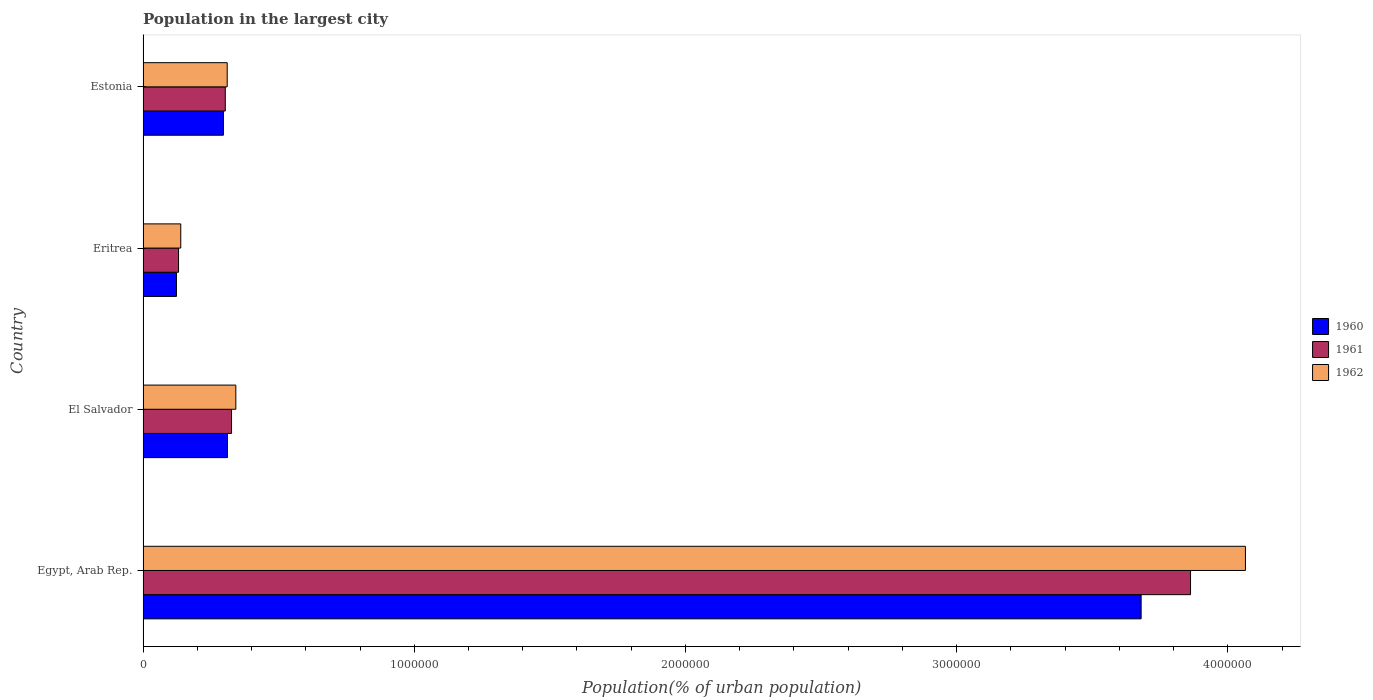How many bars are there on the 4th tick from the top?
Keep it short and to the point. 3. How many bars are there on the 4th tick from the bottom?
Ensure brevity in your answer.  3. What is the label of the 4th group of bars from the top?
Your response must be concise. Egypt, Arab Rep. In how many cases, is the number of bars for a given country not equal to the number of legend labels?
Give a very brief answer. 0. What is the population in the largest city in 1960 in Eritrea?
Offer a very short reply. 1.23e+05. Across all countries, what is the maximum population in the largest city in 1960?
Offer a terse response. 3.68e+06. Across all countries, what is the minimum population in the largest city in 1961?
Provide a short and direct response. 1.31e+05. In which country was the population in the largest city in 1960 maximum?
Ensure brevity in your answer.  Egypt, Arab Rep. In which country was the population in the largest city in 1962 minimum?
Your answer should be compact. Eritrea. What is the total population in the largest city in 1960 in the graph?
Offer a terse response. 4.41e+06. What is the difference between the population in the largest city in 1960 in El Salvador and that in Eritrea?
Keep it short and to the point. 1.88e+05. What is the difference between the population in the largest city in 1960 in El Salvador and the population in the largest city in 1962 in Egypt, Arab Rep.?
Your answer should be very brief. -3.75e+06. What is the average population in the largest city in 1961 per country?
Keep it short and to the point. 1.16e+06. What is the difference between the population in the largest city in 1960 and population in the largest city in 1962 in El Salvador?
Offer a terse response. -3.08e+04. What is the ratio of the population in the largest city in 1960 in El Salvador to that in Estonia?
Provide a short and direct response. 1.05. What is the difference between the highest and the second highest population in the largest city in 1960?
Ensure brevity in your answer.  3.37e+06. What is the difference between the highest and the lowest population in the largest city in 1962?
Ensure brevity in your answer.  3.93e+06. In how many countries, is the population in the largest city in 1960 greater than the average population in the largest city in 1960 taken over all countries?
Provide a short and direct response. 1. What does the 1st bar from the bottom in Egypt, Arab Rep. represents?
Your answer should be compact. 1960. How many bars are there?
Your answer should be very brief. 12. Are all the bars in the graph horizontal?
Provide a short and direct response. Yes. How many countries are there in the graph?
Provide a succinct answer. 4. What is the difference between two consecutive major ticks on the X-axis?
Make the answer very short. 1.00e+06. Does the graph contain any zero values?
Make the answer very short. No. Does the graph contain grids?
Provide a succinct answer. No. How many legend labels are there?
Ensure brevity in your answer.  3. What is the title of the graph?
Provide a succinct answer. Population in the largest city. What is the label or title of the X-axis?
Offer a terse response. Population(% of urban population). What is the Population(% of urban population) in 1960 in Egypt, Arab Rep.?
Your answer should be very brief. 3.68e+06. What is the Population(% of urban population) in 1961 in Egypt, Arab Rep.?
Offer a terse response. 3.86e+06. What is the Population(% of urban population) in 1962 in Egypt, Arab Rep.?
Your answer should be very brief. 4.06e+06. What is the Population(% of urban population) in 1960 in El Salvador?
Offer a very short reply. 3.11e+05. What is the Population(% of urban population) of 1961 in El Salvador?
Provide a succinct answer. 3.26e+05. What is the Population(% of urban population) of 1962 in El Salvador?
Give a very brief answer. 3.42e+05. What is the Population(% of urban population) in 1960 in Eritrea?
Your response must be concise. 1.23e+05. What is the Population(% of urban population) in 1961 in Eritrea?
Your answer should be compact. 1.31e+05. What is the Population(% of urban population) of 1962 in Eritrea?
Provide a succinct answer. 1.39e+05. What is the Population(% of urban population) of 1960 in Estonia?
Provide a succinct answer. 2.96e+05. What is the Population(% of urban population) of 1961 in Estonia?
Keep it short and to the point. 3.03e+05. What is the Population(% of urban population) in 1962 in Estonia?
Ensure brevity in your answer.  3.10e+05. Across all countries, what is the maximum Population(% of urban population) of 1960?
Keep it short and to the point. 3.68e+06. Across all countries, what is the maximum Population(% of urban population) of 1961?
Your answer should be compact. 3.86e+06. Across all countries, what is the maximum Population(% of urban population) in 1962?
Ensure brevity in your answer.  4.06e+06. Across all countries, what is the minimum Population(% of urban population) in 1960?
Your answer should be very brief. 1.23e+05. Across all countries, what is the minimum Population(% of urban population) of 1961?
Provide a short and direct response. 1.31e+05. Across all countries, what is the minimum Population(% of urban population) of 1962?
Provide a short and direct response. 1.39e+05. What is the total Population(% of urban population) of 1960 in the graph?
Offer a very short reply. 4.41e+06. What is the total Population(% of urban population) of 1961 in the graph?
Provide a short and direct response. 4.62e+06. What is the total Population(% of urban population) in 1962 in the graph?
Give a very brief answer. 4.86e+06. What is the difference between the Population(% of urban population) of 1960 in Egypt, Arab Rep. and that in El Salvador?
Make the answer very short. 3.37e+06. What is the difference between the Population(% of urban population) of 1961 in Egypt, Arab Rep. and that in El Salvador?
Offer a terse response. 3.54e+06. What is the difference between the Population(% of urban population) in 1962 in Egypt, Arab Rep. and that in El Salvador?
Make the answer very short. 3.72e+06. What is the difference between the Population(% of urban population) of 1960 in Egypt, Arab Rep. and that in Eritrea?
Give a very brief answer. 3.56e+06. What is the difference between the Population(% of urban population) in 1961 in Egypt, Arab Rep. and that in Eritrea?
Provide a short and direct response. 3.73e+06. What is the difference between the Population(% of urban population) of 1962 in Egypt, Arab Rep. and that in Eritrea?
Provide a short and direct response. 3.93e+06. What is the difference between the Population(% of urban population) in 1960 in Egypt, Arab Rep. and that in Estonia?
Keep it short and to the point. 3.38e+06. What is the difference between the Population(% of urban population) in 1961 in Egypt, Arab Rep. and that in Estonia?
Ensure brevity in your answer.  3.56e+06. What is the difference between the Population(% of urban population) of 1962 in Egypt, Arab Rep. and that in Estonia?
Your response must be concise. 3.75e+06. What is the difference between the Population(% of urban population) of 1960 in El Salvador and that in Eritrea?
Offer a very short reply. 1.88e+05. What is the difference between the Population(% of urban population) of 1961 in El Salvador and that in Eritrea?
Your answer should be compact. 1.95e+05. What is the difference between the Population(% of urban population) in 1962 in El Salvador and that in Eritrea?
Make the answer very short. 2.03e+05. What is the difference between the Population(% of urban population) of 1960 in El Salvador and that in Estonia?
Give a very brief answer. 1.49e+04. What is the difference between the Population(% of urban population) of 1961 in El Salvador and that in Estonia?
Provide a succinct answer. 2.30e+04. What is the difference between the Population(% of urban population) of 1962 in El Salvador and that in Estonia?
Give a very brief answer. 3.18e+04. What is the difference between the Population(% of urban population) in 1960 in Eritrea and that in Estonia?
Provide a short and direct response. -1.73e+05. What is the difference between the Population(% of urban population) of 1961 in Eritrea and that in Estonia?
Offer a terse response. -1.72e+05. What is the difference between the Population(% of urban population) of 1962 in Eritrea and that in Estonia?
Provide a succinct answer. -1.71e+05. What is the difference between the Population(% of urban population) in 1960 in Egypt, Arab Rep. and the Population(% of urban population) in 1961 in El Salvador?
Your answer should be very brief. 3.35e+06. What is the difference between the Population(% of urban population) in 1960 in Egypt, Arab Rep. and the Population(% of urban population) in 1962 in El Salvador?
Provide a short and direct response. 3.34e+06. What is the difference between the Population(% of urban population) in 1961 in Egypt, Arab Rep. and the Population(% of urban population) in 1962 in El Salvador?
Offer a very short reply. 3.52e+06. What is the difference between the Population(% of urban population) in 1960 in Egypt, Arab Rep. and the Population(% of urban population) in 1961 in Eritrea?
Give a very brief answer. 3.55e+06. What is the difference between the Population(% of urban population) of 1960 in Egypt, Arab Rep. and the Population(% of urban population) of 1962 in Eritrea?
Keep it short and to the point. 3.54e+06. What is the difference between the Population(% of urban population) of 1961 in Egypt, Arab Rep. and the Population(% of urban population) of 1962 in Eritrea?
Make the answer very short. 3.72e+06. What is the difference between the Population(% of urban population) in 1960 in Egypt, Arab Rep. and the Population(% of urban population) in 1961 in Estonia?
Your answer should be very brief. 3.38e+06. What is the difference between the Population(% of urban population) in 1960 in Egypt, Arab Rep. and the Population(% of urban population) in 1962 in Estonia?
Make the answer very short. 3.37e+06. What is the difference between the Population(% of urban population) of 1961 in Egypt, Arab Rep. and the Population(% of urban population) of 1962 in Estonia?
Offer a very short reply. 3.55e+06. What is the difference between the Population(% of urban population) of 1960 in El Salvador and the Population(% of urban population) of 1961 in Eritrea?
Keep it short and to the point. 1.80e+05. What is the difference between the Population(% of urban population) of 1960 in El Salvador and the Population(% of urban population) of 1962 in Eritrea?
Offer a very short reply. 1.72e+05. What is the difference between the Population(% of urban population) of 1961 in El Salvador and the Population(% of urban population) of 1962 in Eritrea?
Provide a succinct answer. 1.87e+05. What is the difference between the Population(% of urban population) of 1960 in El Salvador and the Population(% of urban population) of 1961 in Estonia?
Give a very brief answer. 8011. What is the difference between the Population(% of urban population) in 1960 in El Salvador and the Population(% of urban population) in 1962 in Estonia?
Offer a very short reply. 942. What is the difference between the Population(% of urban population) of 1961 in El Salvador and the Population(% of urban population) of 1962 in Estonia?
Give a very brief answer. 1.60e+04. What is the difference between the Population(% of urban population) of 1960 in Eritrea and the Population(% of urban population) of 1961 in Estonia?
Your answer should be very brief. -1.80e+05. What is the difference between the Population(% of urban population) in 1960 in Eritrea and the Population(% of urban population) in 1962 in Estonia?
Your answer should be very brief. -1.87e+05. What is the difference between the Population(% of urban population) in 1961 in Eritrea and the Population(% of urban population) in 1962 in Estonia?
Your answer should be very brief. -1.79e+05. What is the average Population(% of urban population) in 1960 per country?
Provide a short and direct response. 1.10e+06. What is the average Population(% of urban population) in 1961 per country?
Your answer should be very brief. 1.16e+06. What is the average Population(% of urban population) of 1962 per country?
Provide a succinct answer. 1.21e+06. What is the difference between the Population(% of urban population) of 1960 and Population(% of urban population) of 1961 in Egypt, Arab Rep.?
Provide a succinct answer. -1.82e+05. What is the difference between the Population(% of urban population) in 1960 and Population(% of urban population) in 1962 in Egypt, Arab Rep.?
Offer a terse response. -3.85e+05. What is the difference between the Population(% of urban population) of 1961 and Population(% of urban population) of 1962 in Egypt, Arab Rep.?
Your response must be concise. -2.02e+05. What is the difference between the Population(% of urban population) of 1960 and Population(% of urban population) of 1961 in El Salvador?
Offer a terse response. -1.50e+04. What is the difference between the Population(% of urban population) in 1960 and Population(% of urban population) in 1962 in El Salvador?
Give a very brief answer. -3.08e+04. What is the difference between the Population(% of urban population) in 1961 and Population(% of urban population) in 1962 in El Salvador?
Offer a very short reply. -1.58e+04. What is the difference between the Population(% of urban population) of 1960 and Population(% of urban population) of 1961 in Eritrea?
Your answer should be compact. -7673. What is the difference between the Population(% of urban population) of 1960 and Population(% of urban population) of 1962 in Eritrea?
Your answer should be very brief. -1.58e+04. What is the difference between the Population(% of urban population) in 1961 and Population(% of urban population) in 1962 in Eritrea?
Your answer should be very brief. -8161. What is the difference between the Population(% of urban population) in 1960 and Population(% of urban population) in 1961 in Estonia?
Keep it short and to the point. -6898. What is the difference between the Population(% of urban population) of 1960 and Population(% of urban population) of 1962 in Estonia?
Ensure brevity in your answer.  -1.40e+04. What is the difference between the Population(% of urban population) in 1961 and Population(% of urban population) in 1962 in Estonia?
Make the answer very short. -7069. What is the ratio of the Population(% of urban population) of 1960 in Egypt, Arab Rep. to that in El Salvador?
Ensure brevity in your answer.  11.83. What is the ratio of the Population(% of urban population) of 1961 in Egypt, Arab Rep. to that in El Salvador?
Offer a very short reply. 11.84. What is the ratio of the Population(% of urban population) in 1962 in Egypt, Arab Rep. to that in El Salvador?
Offer a very short reply. 11.88. What is the ratio of the Population(% of urban population) in 1960 in Egypt, Arab Rep. to that in Eritrea?
Keep it short and to the point. 29.88. What is the ratio of the Population(% of urban population) in 1961 in Egypt, Arab Rep. to that in Eritrea?
Give a very brief answer. 29.52. What is the ratio of the Population(% of urban population) in 1962 in Egypt, Arab Rep. to that in Eritrea?
Provide a short and direct response. 29.24. What is the ratio of the Population(% of urban population) in 1960 in Egypt, Arab Rep. to that in Estonia?
Offer a very short reply. 12.42. What is the ratio of the Population(% of urban population) in 1961 in Egypt, Arab Rep. to that in Estonia?
Ensure brevity in your answer.  12.74. What is the ratio of the Population(% of urban population) in 1962 in Egypt, Arab Rep. to that in Estonia?
Provide a succinct answer. 13.1. What is the ratio of the Population(% of urban population) in 1960 in El Salvador to that in Eritrea?
Offer a terse response. 2.53. What is the ratio of the Population(% of urban population) in 1961 in El Salvador to that in Eritrea?
Keep it short and to the point. 2.49. What is the ratio of the Population(% of urban population) of 1962 in El Salvador to that in Eritrea?
Offer a very short reply. 2.46. What is the ratio of the Population(% of urban population) in 1960 in El Salvador to that in Estonia?
Provide a short and direct response. 1.05. What is the ratio of the Population(% of urban population) of 1961 in El Salvador to that in Estonia?
Your answer should be very brief. 1.08. What is the ratio of the Population(% of urban population) in 1962 in El Salvador to that in Estonia?
Your response must be concise. 1.1. What is the ratio of the Population(% of urban population) in 1960 in Eritrea to that in Estonia?
Offer a very short reply. 0.42. What is the ratio of the Population(% of urban population) in 1961 in Eritrea to that in Estonia?
Provide a succinct answer. 0.43. What is the ratio of the Population(% of urban population) in 1962 in Eritrea to that in Estonia?
Provide a short and direct response. 0.45. What is the difference between the highest and the second highest Population(% of urban population) of 1960?
Keep it short and to the point. 3.37e+06. What is the difference between the highest and the second highest Population(% of urban population) of 1961?
Provide a succinct answer. 3.54e+06. What is the difference between the highest and the second highest Population(% of urban population) in 1962?
Your answer should be compact. 3.72e+06. What is the difference between the highest and the lowest Population(% of urban population) of 1960?
Ensure brevity in your answer.  3.56e+06. What is the difference between the highest and the lowest Population(% of urban population) in 1961?
Make the answer very short. 3.73e+06. What is the difference between the highest and the lowest Population(% of urban population) of 1962?
Your answer should be compact. 3.93e+06. 